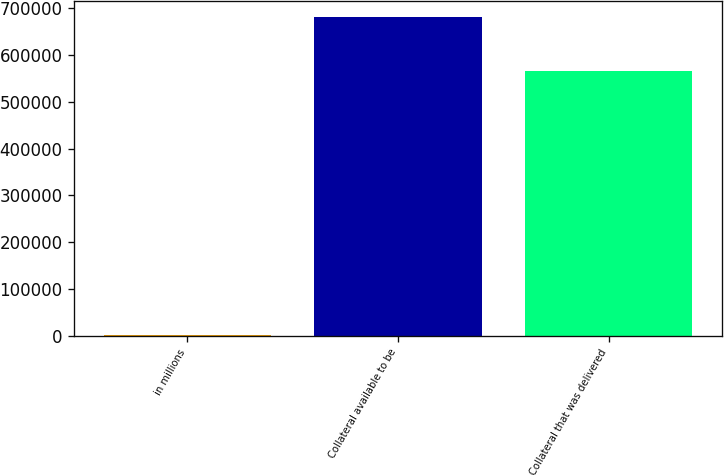<chart> <loc_0><loc_0><loc_500><loc_500><bar_chart><fcel>in millions<fcel>Collateral available to be<fcel>Collateral that was delivered<nl><fcel>2018<fcel>681516<fcel>565625<nl></chart> 